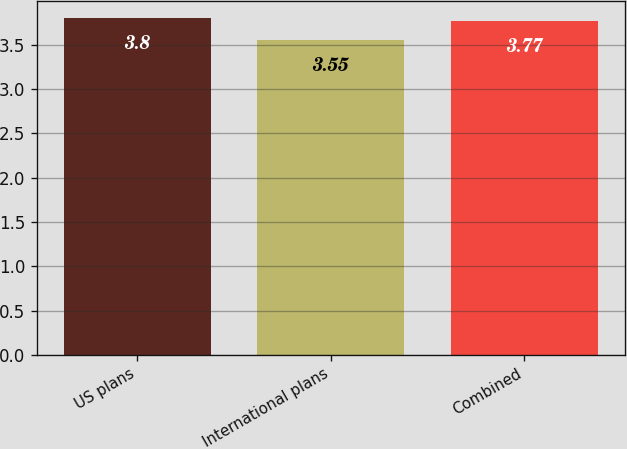Convert chart. <chart><loc_0><loc_0><loc_500><loc_500><bar_chart><fcel>US plans<fcel>International plans<fcel>Combined<nl><fcel>3.8<fcel>3.55<fcel>3.77<nl></chart> 